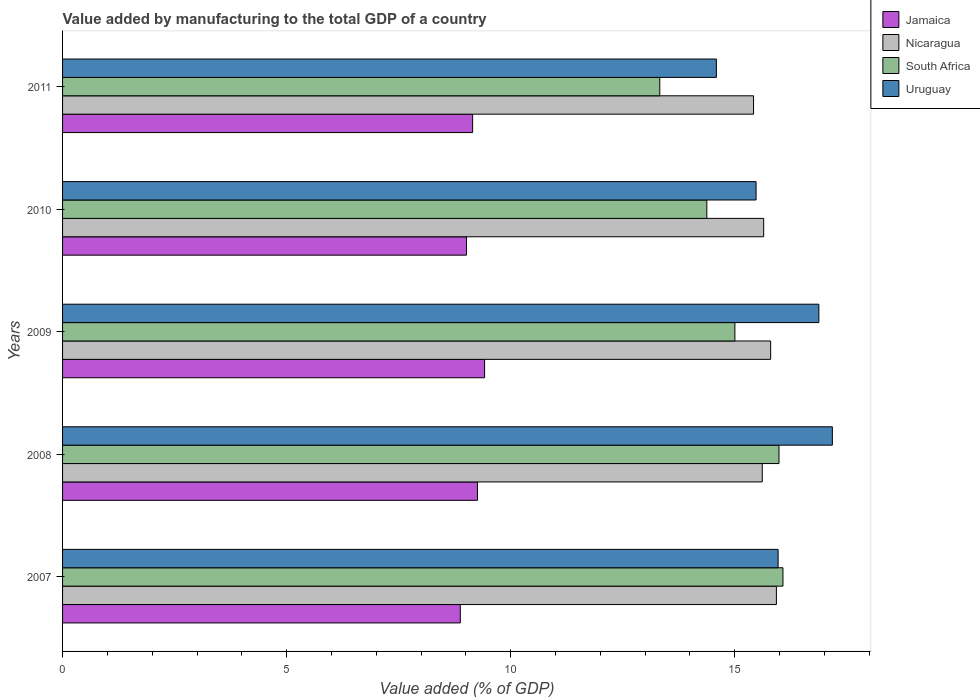Are the number of bars on each tick of the Y-axis equal?
Offer a very short reply. Yes. How many bars are there on the 5th tick from the top?
Your answer should be compact. 4. What is the value added by manufacturing to the total GDP in South Africa in 2008?
Ensure brevity in your answer.  15.99. Across all years, what is the maximum value added by manufacturing to the total GDP in Nicaragua?
Your response must be concise. 15.93. Across all years, what is the minimum value added by manufacturing to the total GDP in Nicaragua?
Make the answer very short. 15.42. What is the total value added by manufacturing to the total GDP in Uruguay in the graph?
Your answer should be very brief. 80.09. What is the difference between the value added by manufacturing to the total GDP in Uruguay in 2007 and that in 2010?
Your answer should be compact. 0.49. What is the difference between the value added by manufacturing to the total GDP in Jamaica in 2011 and the value added by manufacturing to the total GDP in Nicaragua in 2008?
Your response must be concise. -6.46. What is the average value added by manufacturing to the total GDP in Nicaragua per year?
Your answer should be compact. 15.68. In the year 2008, what is the difference between the value added by manufacturing to the total GDP in Uruguay and value added by manufacturing to the total GDP in Nicaragua?
Offer a terse response. 1.56. In how many years, is the value added by manufacturing to the total GDP in Jamaica greater than 4 %?
Your answer should be compact. 5. What is the ratio of the value added by manufacturing to the total GDP in Uruguay in 2008 to that in 2009?
Give a very brief answer. 1.02. What is the difference between the highest and the second highest value added by manufacturing to the total GDP in Nicaragua?
Ensure brevity in your answer.  0.13. What is the difference between the highest and the lowest value added by manufacturing to the total GDP in Nicaragua?
Give a very brief answer. 0.51. What does the 2nd bar from the top in 2007 represents?
Offer a very short reply. South Africa. What does the 1st bar from the bottom in 2009 represents?
Keep it short and to the point. Jamaica. Are all the bars in the graph horizontal?
Make the answer very short. Yes. Does the graph contain any zero values?
Give a very brief answer. No. Where does the legend appear in the graph?
Make the answer very short. Top right. How many legend labels are there?
Keep it short and to the point. 4. How are the legend labels stacked?
Provide a short and direct response. Vertical. What is the title of the graph?
Offer a terse response. Value added by manufacturing to the total GDP of a country. Does "Georgia" appear as one of the legend labels in the graph?
Ensure brevity in your answer.  No. What is the label or title of the X-axis?
Give a very brief answer. Value added (% of GDP). What is the Value added (% of GDP) of Jamaica in 2007?
Offer a very short reply. 8.88. What is the Value added (% of GDP) in Nicaragua in 2007?
Provide a succinct answer. 15.93. What is the Value added (% of GDP) of South Africa in 2007?
Ensure brevity in your answer.  16.08. What is the Value added (% of GDP) of Uruguay in 2007?
Provide a succinct answer. 15.97. What is the Value added (% of GDP) in Jamaica in 2008?
Make the answer very short. 9.26. What is the Value added (% of GDP) of Nicaragua in 2008?
Provide a succinct answer. 15.61. What is the Value added (% of GDP) in South Africa in 2008?
Offer a terse response. 15.99. What is the Value added (% of GDP) of Uruguay in 2008?
Offer a terse response. 17.18. What is the Value added (% of GDP) of Jamaica in 2009?
Give a very brief answer. 9.42. What is the Value added (% of GDP) in Nicaragua in 2009?
Make the answer very short. 15.8. What is the Value added (% of GDP) of South Africa in 2009?
Provide a short and direct response. 15. What is the Value added (% of GDP) of Uruguay in 2009?
Keep it short and to the point. 16.88. What is the Value added (% of GDP) of Jamaica in 2010?
Offer a very short reply. 9.01. What is the Value added (% of GDP) in Nicaragua in 2010?
Make the answer very short. 15.65. What is the Value added (% of GDP) of South Africa in 2010?
Make the answer very short. 14.38. What is the Value added (% of GDP) of Uruguay in 2010?
Keep it short and to the point. 15.48. What is the Value added (% of GDP) of Jamaica in 2011?
Give a very brief answer. 9.15. What is the Value added (% of GDP) in Nicaragua in 2011?
Offer a terse response. 15.42. What is the Value added (% of GDP) in South Africa in 2011?
Your response must be concise. 13.33. What is the Value added (% of GDP) in Uruguay in 2011?
Give a very brief answer. 14.59. Across all years, what is the maximum Value added (% of GDP) of Jamaica?
Provide a short and direct response. 9.42. Across all years, what is the maximum Value added (% of GDP) of Nicaragua?
Offer a terse response. 15.93. Across all years, what is the maximum Value added (% of GDP) in South Africa?
Keep it short and to the point. 16.08. Across all years, what is the maximum Value added (% of GDP) in Uruguay?
Your answer should be compact. 17.18. Across all years, what is the minimum Value added (% of GDP) in Jamaica?
Your response must be concise. 8.88. Across all years, what is the minimum Value added (% of GDP) in Nicaragua?
Offer a very short reply. 15.42. Across all years, what is the minimum Value added (% of GDP) in South Africa?
Ensure brevity in your answer.  13.33. Across all years, what is the minimum Value added (% of GDP) in Uruguay?
Make the answer very short. 14.59. What is the total Value added (% of GDP) in Jamaica in the graph?
Give a very brief answer. 45.72. What is the total Value added (% of GDP) of Nicaragua in the graph?
Offer a terse response. 78.41. What is the total Value added (% of GDP) in South Africa in the graph?
Give a very brief answer. 74.77. What is the total Value added (% of GDP) in Uruguay in the graph?
Ensure brevity in your answer.  80.09. What is the difference between the Value added (% of GDP) in Jamaica in 2007 and that in 2008?
Your answer should be very brief. -0.38. What is the difference between the Value added (% of GDP) in Nicaragua in 2007 and that in 2008?
Your response must be concise. 0.32. What is the difference between the Value added (% of GDP) of South Africa in 2007 and that in 2008?
Offer a very short reply. 0.09. What is the difference between the Value added (% of GDP) in Uruguay in 2007 and that in 2008?
Your response must be concise. -1.21. What is the difference between the Value added (% of GDP) in Jamaica in 2007 and that in 2009?
Your response must be concise. -0.54. What is the difference between the Value added (% of GDP) in Nicaragua in 2007 and that in 2009?
Give a very brief answer. 0.13. What is the difference between the Value added (% of GDP) in South Africa in 2007 and that in 2009?
Offer a terse response. 1.07. What is the difference between the Value added (% of GDP) of Uruguay in 2007 and that in 2009?
Your response must be concise. -0.91. What is the difference between the Value added (% of GDP) of Jamaica in 2007 and that in 2010?
Offer a very short reply. -0.14. What is the difference between the Value added (% of GDP) in Nicaragua in 2007 and that in 2010?
Provide a short and direct response. 0.28. What is the difference between the Value added (% of GDP) of South Africa in 2007 and that in 2010?
Your response must be concise. 1.7. What is the difference between the Value added (% of GDP) in Uruguay in 2007 and that in 2010?
Provide a succinct answer. 0.49. What is the difference between the Value added (% of GDP) in Jamaica in 2007 and that in 2011?
Make the answer very short. -0.27. What is the difference between the Value added (% of GDP) of Nicaragua in 2007 and that in 2011?
Provide a short and direct response. 0.51. What is the difference between the Value added (% of GDP) in South Africa in 2007 and that in 2011?
Offer a very short reply. 2.75. What is the difference between the Value added (% of GDP) of Uruguay in 2007 and that in 2011?
Offer a terse response. 1.38. What is the difference between the Value added (% of GDP) of Jamaica in 2008 and that in 2009?
Offer a very short reply. -0.16. What is the difference between the Value added (% of GDP) of Nicaragua in 2008 and that in 2009?
Offer a very short reply. -0.19. What is the difference between the Value added (% of GDP) in South Africa in 2008 and that in 2009?
Offer a terse response. 0.98. What is the difference between the Value added (% of GDP) of Uruguay in 2008 and that in 2009?
Your answer should be very brief. 0.3. What is the difference between the Value added (% of GDP) in Jamaica in 2008 and that in 2010?
Provide a succinct answer. 0.24. What is the difference between the Value added (% of GDP) of Nicaragua in 2008 and that in 2010?
Keep it short and to the point. -0.03. What is the difference between the Value added (% of GDP) in South Africa in 2008 and that in 2010?
Your response must be concise. 1.61. What is the difference between the Value added (% of GDP) of Uruguay in 2008 and that in 2010?
Ensure brevity in your answer.  1.7. What is the difference between the Value added (% of GDP) in Jamaica in 2008 and that in 2011?
Your answer should be very brief. 0.11. What is the difference between the Value added (% of GDP) of Nicaragua in 2008 and that in 2011?
Give a very brief answer. 0.19. What is the difference between the Value added (% of GDP) of South Africa in 2008 and that in 2011?
Give a very brief answer. 2.66. What is the difference between the Value added (% of GDP) of Uruguay in 2008 and that in 2011?
Provide a succinct answer. 2.59. What is the difference between the Value added (% of GDP) in Jamaica in 2009 and that in 2010?
Provide a succinct answer. 0.4. What is the difference between the Value added (% of GDP) of Nicaragua in 2009 and that in 2010?
Your answer should be compact. 0.16. What is the difference between the Value added (% of GDP) in South Africa in 2009 and that in 2010?
Your answer should be very brief. 0.63. What is the difference between the Value added (% of GDP) in Uruguay in 2009 and that in 2010?
Provide a succinct answer. 1.4. What is the difference between the Value added (% of GDP) of Jamaica in 2009 and that in 2011?
Give a very brief answer. 0.27. What is the difference between the Value added (% of GDP) of Nicaragua in 2009 and that in 2011?
Provide a succinct answer. 0.38. What is the difference between the Value added (% of GDP) of South Africa in 2009 and that in 2011?
Offer a very short reply. 1.68. What is the difference between the Value added (% of GDP) in Uruguay in 2009 and that in 2011?
Provide a short and direct response. 2.29. What is the difference between the Value added (% of GDP) in Jamaica in 2010 and that in 2011?
Your answer should be very brief. -0.14. What is the difference between the Value added (% of GDP) in Nicaragua in 2010 and that in 2011?
Provide a succinct answer. 0.23. What is the difference between the Value added (% of GDP) of South Africa in 2010 and that in 2011?
Offer a very short reply. 1.05. What is the difference between the Value added (% of GDP) of Uruguay in 2010 and that in 2011?
Give a very brief answer. 0.89. What is the difference between the Value added (% of GDP) in Jamaica in 2007 and the Value added (% of GDP) in Nicaragua in 2008?
Your answer should be compact. -6.74. What is the difference between the Value added (% of GDP) in Jamaica in 2007 and the Value added (% of GDP) in South Africa in 2008?
Your response must be concise. -7.11. What is the difference between the Value added (% of GDP) of Jamaica in 2007 and the Value added (% of GDP) of Uruguay in 2008?
Provide a succinct answer. -8.3. What is the difference between the Value added (% of GDP) in Nicaragua in 2007 and the Value added (% of GDP) in South Africa in 2008?
Ensure brevity in your answer.  -0.06. What is the difference between the Value added (% of GDP) of Nicaragua in 2007 and the Value added (% of GDP) of Uruguay in 2008?
Keep it short and to the point. -1.25. What is the difference between the Value added (% of GDP) of South Africa in 2007 and the Value added (% of GDP) of Uruguay in 2008?
Provide a short and direct response. -1.1. What is the difference between the Value added (% of GDP) of Jamaica in 2007 and the Value added (% of GDP) of Nicaragua in 2009?
Your answer should be compact. -6.93. What is the difference between the Value added (% of GDP) in Jamaica in 2007 and the Value added (% of GDP) in South Africa in 2009?
Give a very brief answer. -6.13. What is the difference between the Value added (% of GDP) of Jamaica in 2007 and the Value added (% of GDP) of Uruguay in 2009?
Ensure brevity in your answer.  -8. What is the difference between the Value added (% of GDP) in Nicaragua in 2007 and the Value added (% of GDP) in South Africa in 2009?
Keep it short and to the point. 0.93. What is the difference between the Value added (% of GDP) in Nicaragua in 2007 and the Value added (% of GDP) in Uruguay in 2009?
Your answer should be very brief. -0.95. What is the difference between the Value added (% of GDP) of South Africa in 2007 and the Value added (% of GDP) of Uruguay in 2009?
Provide a short and direct response. -0.8. What is the difference between the Value added (% of GDP) of Jamaica in 2007 and the Value added (% of GDP) of Nicaragua in 2010?
Offer a terse response. -6.77. What is the difference between the Value added (% of GDP) in Jamaica in 2007 and the Value added (% of GDP) in South Africa in 2010?
Give a very brief answer. -5.5. What is the difference between the Value added (% of GDP) of Jamaica in 2007 and the Value added (% of GDP) of Uruguay in 2010?
Make the answer very short. -6.6. What is the difference between the Value added (% of GDP) in Nicaragua in 2007 and the Value added (% of GDP) in South Africa in 2010?
Offer a very short reply. 1.55. What is the difference between the Value added (% of GDP) of Nicaragua in 2007 and the Value added (% of GDP) of Uruguay in 2010?
Your response must be concise. 0.45. What is the difference between the Value added (% of GDP) in South Africa in 2007 and the Value added (% of GDP) in Uruguay in 2010?
Your answer should be very brief. 0.6. What is the difference between the Value added (% of GDP) in Jamaica in 2007 and the Value added (% of GDP) in Nicaragua in 2011?
Your response must be concise. -6.54. What is the difference between the Value added (% of GDP) of Jamaica in 2007 and the Value added (% of GDP) of South Africa in 2011?
Ensure brevity in your answer.  -4.45. What is the difference between the Value added (% of GDP) in Jamaica in 2007 and the Value added (% of GDP) in Uruguay in 2011?
Your answer should be very brief. -5.71. What is the difference between the Value added (% of GDP) of Nicaragua in 2007 and the Value added (% of GDP) of South Africa in 2011?
Make the answer very short. 2.6. What is the difference between the Value added (% of GDP) in Nicaragua in 2007 and the Value added (% of GDP) in Uruguay in 2011?
Offer a very short reply. 1.34. What is the difference between the Value added (% of GDP) in South Africa in 2007 and the Value added (% of GDP) in Uruguay in 2011?
Your answer should be very brief. 1.49. What is the difference between the Value added (% of GDP) in Jamaica in 2008 and the Value added (% of GDP) in Nicaragua in 2009?
Your answer should be compact. -6.54. What is the difference between the Value added (% of GDP) in Jamaica in 2008 and the Value added (% of GDP) in South Africa in 2009?
Provide a succinct answer. -5.75. What is the difference between the Value added (% of GDP) in Jamaica in 2008 and the Value added (% of GDP) in Uruguay in 2009?
Your answer should be compact. -7.62. What is the difference between the Value added (% of GDP) in Nicaragua in 2008 and the Value added (% of GDP) in South Africa in 2009?
Provide a short and direct response. 0.61. What is the difference between the Value added (% of GDP) in Nicaragua in 2008 and the Value added (% of GDP) in Uruguay in 2009?
Provide a succinct answer. -1.26. What is the difference between the Value added (% of GDP) in South Africa in 2008 and the Value added (% of GDP) in Uruguay in 2009?
Offer a very short reply. -0.89. What is the difference between the Value added (% of GDP) of Jamaica in 2008 and the Value added (% of GDP) of Nicaragua in 2010?
Keep it short and to the point. -6.39. What is the difference between the Value added (% of GDP) of Jamaica in 2008 and the Value added (% of GDP) of South Africa in 2010?
Make the answer very short. -5.12. What is the difference between the Value added (% of GDP) in Jamaica in 2008 and the Value added (% of GDP) in Uruguay in 2010?
Provide a short and direct response. -6.22. What is the difference between the Value added (% of GDP) of Nicaragua in 2008 and the Value added (% of GDP) of South Africa in 2010?
Provide a short and direct response. 1.24. What is the difference between the Value added (% of GDP) of Nicaragua in 2008 and the Value added (% of GDP) of Uruguay in 2010?
Provide a short and direct response. 0.14. What is the difference between the Value added (% of GDP) in South Africa in 2008 and the Value added (% of GDP) in Uruguay in 2010?
Provide a succinct answer. 0.51. What is the difference between the Value added (% of GDP) in Jamaica in 2008 and the Value added (% of GDP) in Nicaragua in 2011?
Make the answer very short. -6.16. What is the difference between the Value added (% of GDP) of Jamaica in 2008 and the Value added (% of GDP) of South Africa in 2011?
Your answer should be very brief. -4.07. What is the difference between the Value added (% of GDP) in Jamaica in 2008 and the Value added (% of GDP) in Uruguay in 2011?
Offer a very short reply. -5.33. What is the difference between the Value added (% of GDP) in Nicaragua in 2008 and the Value added (% of GDP) in South Africa in 2011?
Provide a short and direct response. 2.29. What is the difference between the Value added (% of GDP) in Nicaragua in 2008 and the Value added (% of GDP) in Uruguay in 2011?
Make the answer very short. 1.02. What is the difference between the Value added (% of GDP) of South Africa in 2008 and the Value added (% of GDP) of Uruguay in 2011?
Your answer should be compact. 1.4. What is the difference between the Value added (% of GDP) in Jamaica in 2009 and the Value added (% of GDP) in Nicaragua in 2010?
Offer a terse response. -6.23. What is the difference between the Value added (% of GDP) in Jamaica in 2009 and the Value added (% of GDP) in South Africa in 2010?
Your answer should be compact. -4.96. What is the difference between the Value added (% of GDP) of Jamaica in 2009 and the Value added (% of GDP) of Uruguay in 2010?
Give a very brief answer. -6.06. What is the difference between the Value added (% of GDP) of Nicaragua in 2009 and the Value added (% of GDP) of South Africa in 2010?
Give a very brief answer. 1.42. What is the difference between the Value added (% of GDP) in Nicaragua in 2009 and the Value added (% of GDP) in Uruguay in 2010?
Keep it short and to the point. 0.33. What is the difference between the Value added (% of GDP) in South Africa in 2009 and the Value added (% of GDP) in Uruguay in 2010?
Provide a short and direct response. -0.47. What is the difference between the Value added (% of GDP) in Jamaica in 2009 and the Value added (% of GDP) in Nicaragua in 2011?
Keep it short and to the point. -6. What is the difference between the Value added (% of GDP) in Jamaica in 2009 and the Value added (% of GDP) in South Africa in 2011?
Provide a succinct answer. -3.91. What is the difference between the Value added (% of GDP) in Jamaica in 2009 and the Value added (% of GDP) in Uruguay in 2011?
Make the answer very short. -5.17. What is the difference between the Value added (% of GDP) in Nicaragua in 2009 and the Value added (% of GDP) in South Africa in 2011?
Offer a very short reply. 2.47. What is the difference between the Value added (% of GDP) in Nicaragua in 2009 and the Value added (% of GDP) in Uruguay in 2011?
Your response must be concise. 1.21. What is the difference between the Value added (% of GDP) in South Africa in 2009 and the Value added (% of GDP) in Uruguay in 2011?
Ensure brevity in your answer.  0.41. What is the difference between the Value added (% of GDP) of Jamaica in 2010 and the Value added (% of GDP) of Nicaragua in 2011?
Make the answer very short. -6.41. What is the difference between the Value added (% of GDP) of Jamaica in 2010 and the Value added (% of GDP) of South Africa in 2011?
Offer a terse response. -4.31. What is the difference between the Value added (% of GDP) in Jamaica in 2010 and the Value added (% of GDP) in Uruguay in 2011?
Your answer should be compact. -5.58. What is the difference between the Value added (% of GDP) in Nicaragua in 2010 and the Value added (% of GDP) in South Africa in 2011?
Provide a succinct answer. 2.32. What is the difference between the Value added (% of GDP) in Nicaragua in 2010 and the Value added (% of GDP) in Uruguay in 2011?
Offer a terse response. 1.06. What is the difference between the Value added (% of GDP) of South Africa in 2010 and the Value added (% of GDP) of Uruguay in 2011?
Provide a short and direct response. -0.21. What is the average Value added (% of GDP) of Jamaica per year?
Keep it short and to the point. 9.14. What is the average Value added (% of GDP) in Nicaragua per year?
Your answer should be compact. 15.68. What is the average Value added (% of GDP) of South Africa per year?
Give a very brief answer. 14.95. What is the average Value added (% of GDP) of Uruguay per year?
Offer a terse response. 16.02. In the year 2007, what is the difference between the Value added (% of GDP) in Jamaica and Value added (% of GDP) in Nicaragua?
Give a very brief answer. -7.05. In the year 2007, what is the difference between the Value added (% of GDP) of Jamaica and Value added (% of GDP) of South Africa?
Your answer should be compact. -7.2. In the year 2007, what is the difference between the Value added (% of GDP) of Jamaica and Value added (% of GDP) of Uruguay?
Your answer should be compact. -7.09. In the year 2007, what is the difference between the Value added (% of GDP) in Nicaragua and Value added (% of GDP) in South Africa?
Your answer should be compact. -0.15. In the year 2007, what is the difference between the Value added (% of GDP) in Nicaragua and Value added (% of GDP) in Uruguay?
Offer a very short reply. -0.04. In the year 2007, what is the difference between the Value added (% of GDP) in South Africa and Value added (% of GDP) in Uruguay?
Keep it short and to the point. 0.11. In the year 2008, what is the difference between the Value added (% of GDP) of Jamaica and Value added (% of GDP) of Nicaragua?
Provide a succinct answer. -6.36. In the year 2008, what is the difference between the Value added (% of GDP) in Jamaica and Value added (% of GDP) in South Africa?
Make the answer very short. -6.73. In the year 2008, what is the difference between the Value added (% of GDP) in Jamaica and Value added (% of GDP) in Uruguay?
Your answer should be compact. -7.92. In the year 2008, what is the difference between the Value added (% of GDP) in Nicaragua and Value added (% of GDP) in South Africa?
Ensure brevity in your answer.  -0.37. In the year 2008, what is the difference between the Value added (% of GDP) of Nicaragua and Value added (% of GDP) of Uruguay?
Your response must be concise. -1.56. In the year 2008, what is the difference between the Value added (% of GDP) in South Africa and Value added (% of GDP) in Uruguay?
Provide a succinct answer. -1.19. In the year 2009, what is the difference between the Value added (% of GDP) in Jamaica and Value added (% of GDP) in Nicaragua?
Offer a very short reply. -6.38. In the year 2009, what is the difference between the Value added (% of GDP) of Jamaica and Value added (% of GDP) of South Africa?
Your answer should be very brief. -5.59. In the year 2009, what is the difference between the Value added (% of GDP) of Jamaica and Value added (% of GDP) of Uruguay?
Provide a succinct answer. -7.46. In the year 2009, what is the difference between the Value added (% of GDP) of Nicaragua and Value added (% of GDP) of South Africa?
Give a very brief answer. 0.8. In the year 2009, what is the difference between the Value added (% of GDP) of Nicaragua and Value added (% of GDP) of Uruguay?
Offer a terse response. -1.08. In the year 2009, what is the difference between the Value added (% of GDP) in South Africa and Value added (% of GDP) in Uruguay?
Offer a terse response. -1.87. In the year 2010, what is the difference between the Value added (% of GDP) of Jamaica and Value added (% of GDP) of Nicaragua?
Make the answer very short. -6.63. In the year 2010, what is the difference between the Value added (% of GDP) of Jamaica and Value added (% of GDP) of South Africa?
Provide a short and direct response. -5.36. In the year 2010, what is the difference between the Value added (% of GDP) of Jamaica and Value added (% of GDP) of Uruguay?
Give a very brief answer. -6.46. In the year 2010, what is the difference between the Value added (% of GDP) of Nicaragua and Value added (% of GDP) of South Africa?
Give a very brief answer. 1.27. In the year 2010, what is the difference between the Value added (% of GDP) of Nicaragua and Value added (% of GDP) of Uruguay?
Your answer should be compact. 0.17. In the year 2010, what is the difference between the Value added (% of GDP) in South Africa and Value added (% of GDP) in Uruguay?
Provide a short and direct response. -1.1. In the year 2011, what is the difference between the Value added (% of GDP) of Jamaica and Value added (% of GDP) of Nicaragua?
Make the answer very short. -6.27. In the year 2011, what is the difference between the Value added (% of GDP) of Jamaica and Value added (% of GDP) of South Africa?
Make the answer very short. -4.18. In the year 2011, what is the difference between the Value added (% of GDP) of Jamaica and Value added (% of GDP) of Uruguay?
Make the answer very short. -5.44. In the year 2011, what is the difference between the Value added (% of GDP) in Nicaragua and Value added (% of GDP) in South Africa?
Your answer should be compact. 2.09. In the year 2011, what is the difference between the Value added (% of GDP) of Nicaragua and Value added (% of GDP) of Uruguay?
Provide a succinct answer. 0.83. In the year 2011, what is the difference between the Value added (% of GDP) of South Africa and Value added (% of GDP) of Uruguay?
Keep it short and to the point. -1.26. What is the ratio of the Value added (% of GDP) of Jamaica in 2007 to that in 2008?
Your answer should be very brief. 0.96. What is the ratio of the Value added (% of GDP) of Nicaragua in 2007 to that in 2008?
Give a very brief answer. 1.02. What is the ratio of the Value added (% of GDP) in Uruguay in 2007 to that in 2008?
Your answer should be very brief. 0.93. What is the ratio of the Value added (% of GDP) of Jamaica in 2007 to that in 2009?
Offer a terse response. 0.94. What is the ratio of the Value added (% of GDP) in Nicaragua in 2007 to that in 2009?
Your answer should be compact. 1.01. What is the ratio of the Value added (% of GDP) in South Africa in 2007 to that in 2009?
Provide a short and direct response. 1.07. What is the ratio of the Value added (% of GDP) in Uruguay in 2007 to that in 2009?
Make the answer very short. 0.95. What is the ratio of the Value added (% of GDP) of Jamaica in 2007 to that in 2010?
Your response must be concise. 0.98. What is the ratio of the Value added (% of GDP) of Nicaragua in 2007 to that in 2010?
Make the answer very short. 1.02. What is the ratio of the Value added (% of GDP) in South Africa in 2007 to that in 2010?
Your answer should be compact. 1.12. What is the ratio of the Value added (% of GDP) in Uruguay in 2007 to that in 2010?
Make the answer very short. 1.03. What is the ratio of the Value added (% of GDP) of Jamaica in 2007 to that in 2011?
Give a very brief answer. 0.97. What is the ratio of the Value added (% of GDP) of Nicaragua in 2007 to that in 2011?
Your answer should be compact. 1.03. What is the ratio of the Value added (% of GDP) of South Africa in 2007 to that in 2011?
Make the answer very short. 1.21. What is the ratio of the Value added (% of GDP) of Uruguay in 2007 to that in 2011?
Offer a terse response. 1.09. What is the ratio of the Value added (% of GDP) in South Africa in 2008 to that in 2009?
Your response must be concise. 1.07. What is the ratio of the Value added (% of GDP) in Uruguay in 2008 to that in 2009?
Give a very brief answer. 1.02. What is the ratio of the Value added (% of GDP) of Jamaica in 2008 to that in 2010?
Your answer should be very brief. 1.03. What is the ratio of the Value added (% of GDP) of South Africa in 2008 to that in 2010?
Give a very brief answer. 1.11. What is the ratio of the Value added (% of GDP) of Uruguay in 2008 to that in 2010?
Provide a succinct answer. 1.11. What is the ratio of the Value added (% of GDP) in Jamaica in 2008 to that in 2011?
Provide a short and direct response. 1.01. What is the ratio of the Value added (% of GDP) in Nicaragua in 2008 to that in 2011?
Your answer should be very brief. 1.01. What is the ratio of the Value added (% of GDP) of South Africa in 2008 to that in 2011?
Give a very brief answer. 1.2. What is the ratio of the Value added (% of GDP) in Uruguay in 2008 to that in 2011?
Your response must be concise. 1.18. What is the ratio of the Value added (% of GDP) in Jamaica in 2009 to that in 2010?
Provide a succinct answer. 1.04. What is the ratio of the Value added (% of GDP) in Nicaragua in 2009 to that in 2010?
Give a very brief answer. 1.01. What is the ratio of the Value added (% of GDP) of South Africa in 2009 to that in 2010?
Make the answer very short. 1.04. What is the ratio of the Value added (% of GDP) in Uruguay in 2009 to that in 2010?
Your answer should be very brief. 1.09. What is the ratio of the Value added (% of GDP) of Jamaica in 2009 to that in 2011?
Keep it short and to the point. 1.03. What is the ratio of the Value added (% of GDP) of Nicaragua in 2009 to that in 2011?
Provide a succinct answer. 1.02. What is the ratio of the Value added (% of GDP) in South Africa in 2009 to that in 2011?
Your answer should be compact. 1.13. What is the ratio of the Value added (% of GDP) of Uruguay in 2009 to that in 2011?
Provide a short and direct response. 1.16. What is the ratio of the Value added (% of GDP) in Nicaragua in 2010 to that in 2011?
Offer a terse response. 1.01. What is the ratio of the Value added (% of GDP) in South Africa in 2010 to that in 2011?
Keep it short and to the point. 1.08. What is the ratio of the Value added (% of GDP) in Uruguay in 2010 to that in 2011?
Your answer should be very brief. 1.06. What is the difference between the highest and the second highest Value added (% of GDP) of Jamaica?
Ensure brevity in your answer.  0.16. What is the difference between the highest and the second highest Value added (% of GDP) of Nicaragua?
Ensure brevity in your answer.  0.13. What is the difference between the highest and the second highest Value added (% of GDP) of South Africa?
Offer a terse response. 0.09. What is the difference between the highest and the second highest Value added (% of GDP) in Uruguay?
Your answer should be compact. 0.3. What is the difference between the highest and the lowest Value added (% of GDP) in Jamaica?
Provide a succinct answer. 0.54. What is the difference between the highest and the lowest Value added (% of GDP) of Nicaragua?
Your response must be concise. 0.51. What is the difference between the highest and the lowest Value added (% of GDP) in South Africa?
Give a very brief answer. 2.75. What is the difference between the highest and the lowest Value added (% of GDP) in Uruguay?
Offer a very short reply. 2.59. 